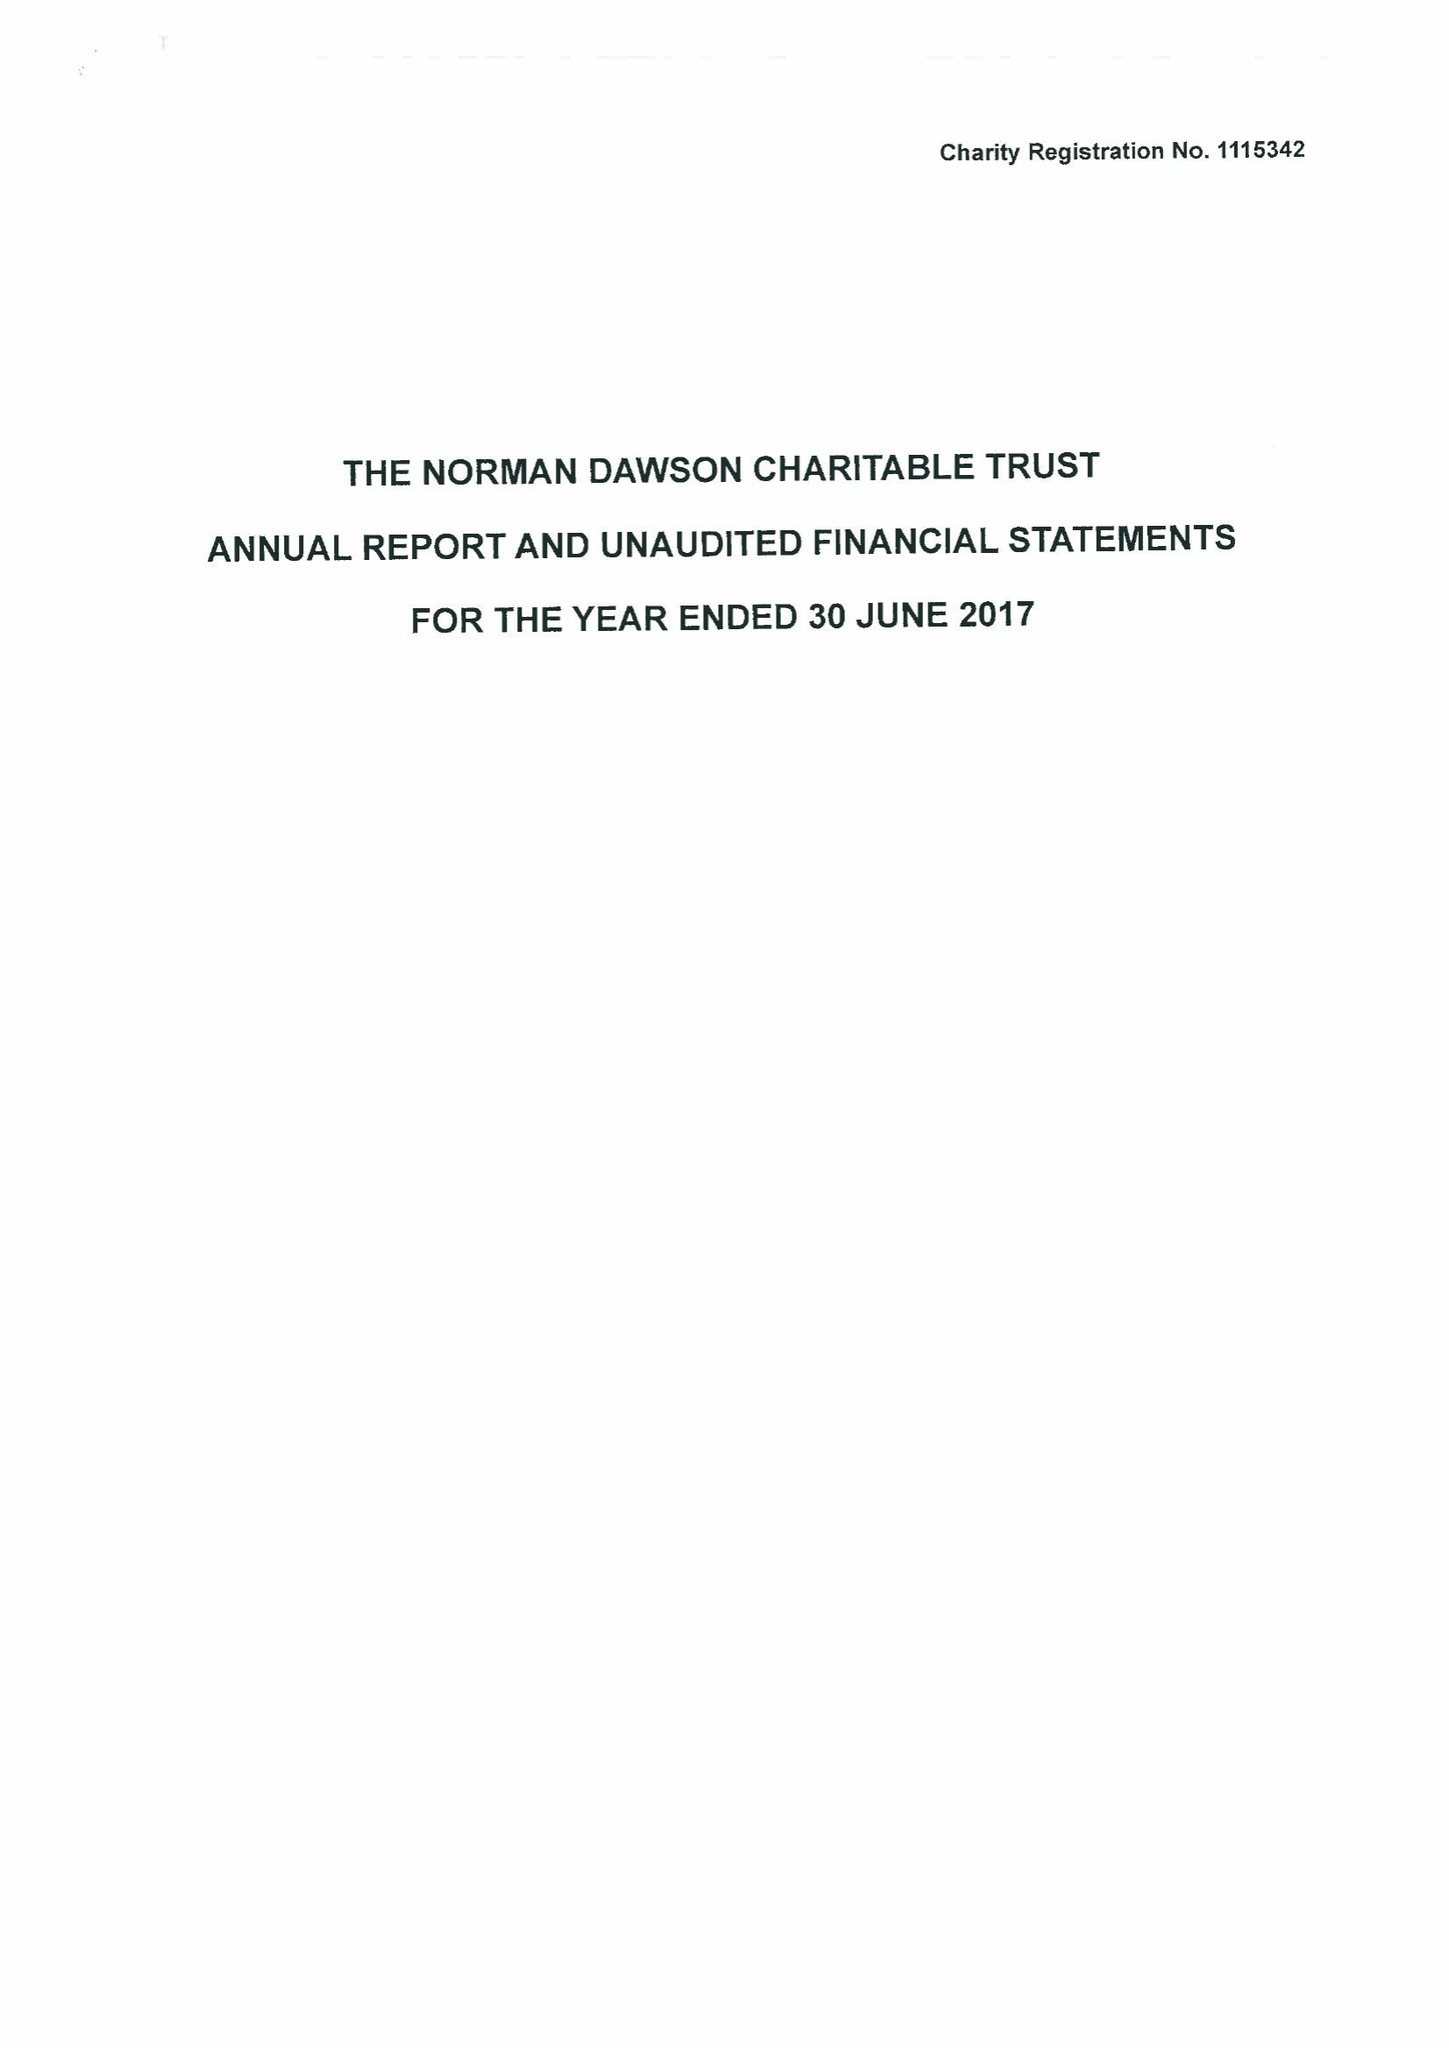What is the value for the charity_number?
Answer the question using a single word or phrase. 1115342 